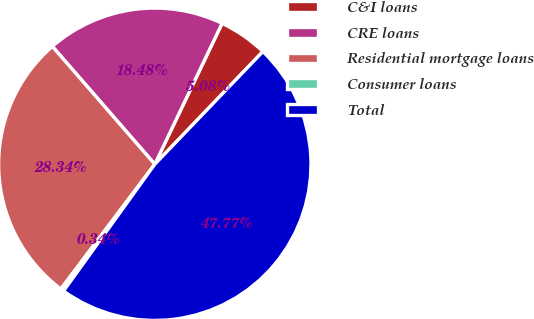Convert chart. <chart><loc_0><loc_0><loc_500><loc_500><pie_chart><fcel>C&I loans<fcel>CRE loans<fcel>Residential mortgage loans<fcel>Consumer loans<fcel>Total<nl><fcel>5.08%<fcel>18.48%<fcel>28.34%<fcel>0.34%<fcel>47.77%<nl></chart> 